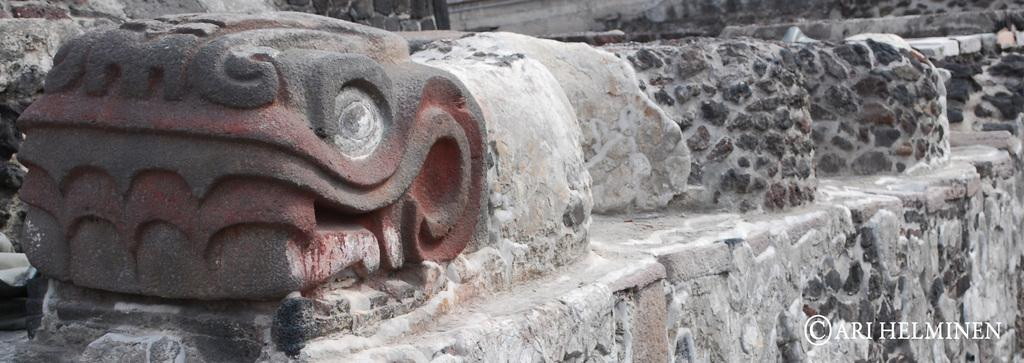What type of art is depicted in the image? There is stone carving in the image. What other architectural features can be seen in the image? There are stone walls in the image. Is there any additional information or markings in the image? Yes, there is a watermark in the bottom right corner of the image. How many thumbs can be seen in the image? There are no thumbs visible in the image. What is the range of motion of the stone carving in the image? The stone carving is a static object and does not have a range of motion. 